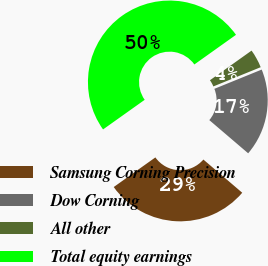Convert chart to OTSL. <chart><loc_0><loc_0><loc_500><loc_500><pie_chart><fcel>Samsung Corning Precision<fcel>Dow Corning<fcel>All other<fcel>Total equity earnings<nl><fcel>28.91%<fcel>17.4%<fcel>3.7%<fcel>50.0%<nl></chart> 